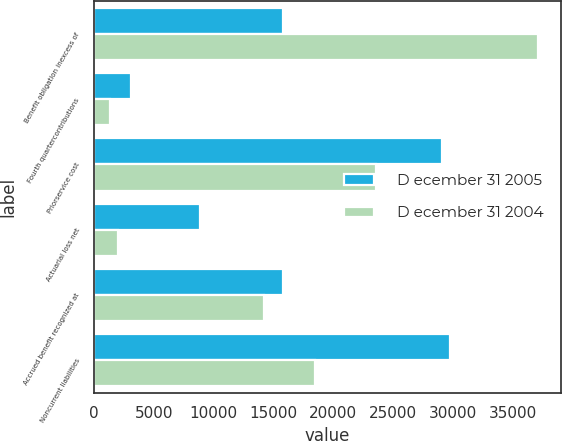<chart> <loc_0><loc_0><loc_500><loc_500><stacked_bar_chart><ecel><fcel>Benefit obligation inexcess of<fcel>Fourth quartercontributions<fcel>Priorservice cost<fcel>Actuarial loss net<fcel>Accrued benefit recognized at<fcel>Noncurrent liabilities<nl><fcel>D ecember 31 2005<fcel>15803<fcel>3125<fcel>29089<fcel>8874<fcel>15803<fcel>29764<nl><fcel>D ecember 31 2004<fcel>37123<fcel>1355<fcel>23539<fcel>2003<fcel>14232<fcel>18487<nl></chart> 